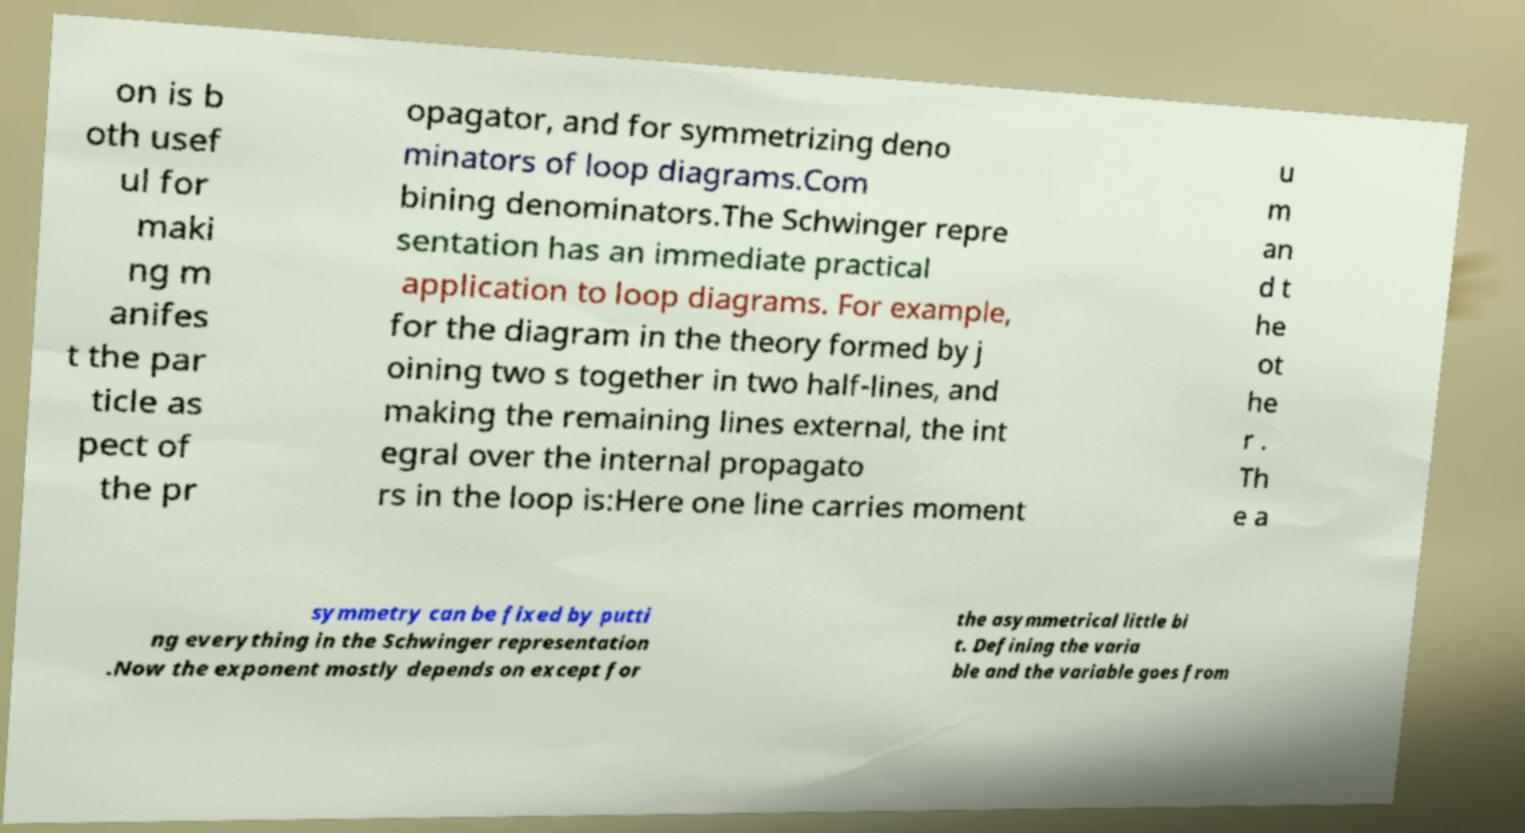Can you accurately transcribe the text from the provided image for me? on is b oth usef ul for maki ng m anifes t the par ticle as pect of the pr opagator, and for symmetrizing deno minators of loop diagrams.Com bining denominators.The Schwinger repre sentation has an immediate practical application to loop diagrams. For example, for the diagram in the theory formed by j oining two s together in two half-lines, and making the remaining lines external, the int egral over the internal propagato rs in the loop is:Here one line carries moment u m an d t he ot he r . Th e a symmetry can be fixed by putti ng everything in the Schwinger representation .Now the exponent mostly depends on except for the asymmetrical little bi t. Defining the varia ble and the variable goes from 